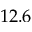Convert formula to latex. <formula><loc_0><loc_0><loc_500><loc_500>1 2 . 6</formula> 